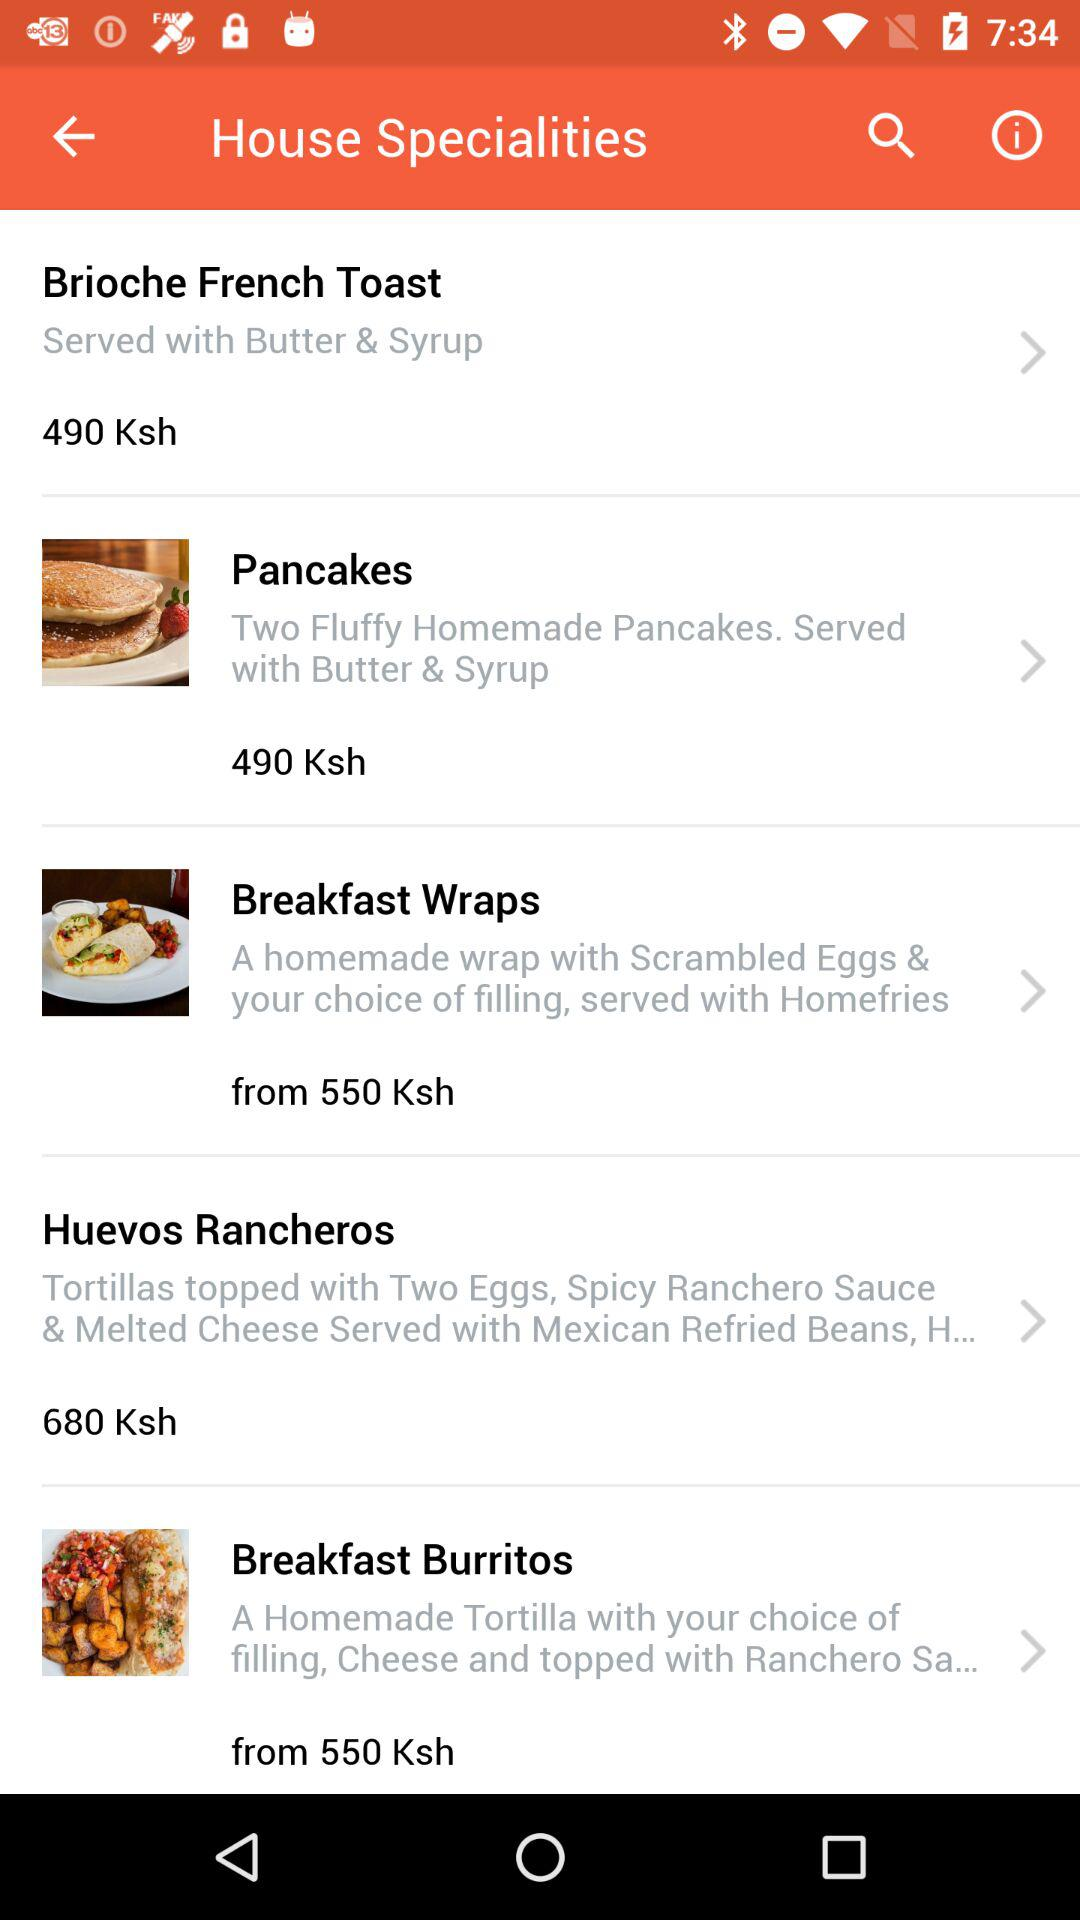What are the condiments served with "Brioche French Toast"? The condiments served with "Brioche French Toast" are butter and syrup. 